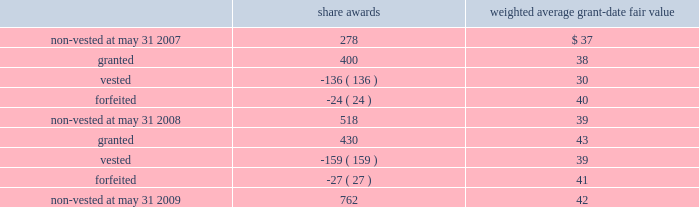Notes to consolidated financial statements 2014 ( continued ) the table summarizes the changes in non-vested restricted stock awards for the year ended may 31 , 2009 ( share awards in thousands ) : share awards weighted average grant-date fair value .
The weighted average grant-date fair value of share awards granted in the years ended may 31 , 2008 and 2007 was $ 38 and $ 45 , respectively .
The total fair value of share awards vested during the years ended may 31 , 2009 , 2008 and 2007 was $ 6.2 million , $ 4.1 million and $ 1.7 million , respectively .
We recognized compensation expense for restricted stock of $ 9.0 million , $ 5.7 million , and $ 2.7 million in the years ended may 31 , 2009 , 2008 and 2007 .
As of may 31 , 2009 , there was $ 23.5 million of total unrecognized compensation cost related to unvested restricted stock awards that is expected to be recognized over a weighted average period of 2.9 years .
Employee stock purchase plan we have an employee stock purchase plan under which the sale of 2.4 million shares of our common stock has been authorized .
Employees may designate up to the lesser of $ 25000 or 20% ( 20 % ) of their annual compensation for the purchase of stock .
The price for shares purchased under the plan is 85% ( 85 % ) of the market value on the last day of the quarterly purchase period .
As of may 31 , 2009 , 0.8 million shares had been issued under this plan , with 1.6 million shares reserved for future issuance .
The weighted average grant-date fair value of each designated share purchased under this plan was $ 6 , $ 6 and $ 8 in the years ended may 31 , 2009 , 2008 and 2007 , respectively .
These values represent the fair value of the 15% ( 15 % ) discount .
Note 12 2014segment information general information during fiscal 2009 , we began assessing our operating performance using a new segment structure .
We made this change as a result of our june 30 , 2008 acquisition of 51% ( 51 % ) of hsbc merchant services llp in the united kingdom , in addition to anticipated future international expansion .
Beginning with the quarter ended august 31 , 2008 , the reportable segments are defined as north america merchant services , international merchant services , and money transfer .
The following tables reflect these changes and such reportable segments for fiscal years 2009 , 2008 , and 2007. .
What is the total value of non-vested shares as of may 31 , 2009 , ( in millions ) ? 
Computations: ((762 * 42) / 1000)
Answer: 32.004. 